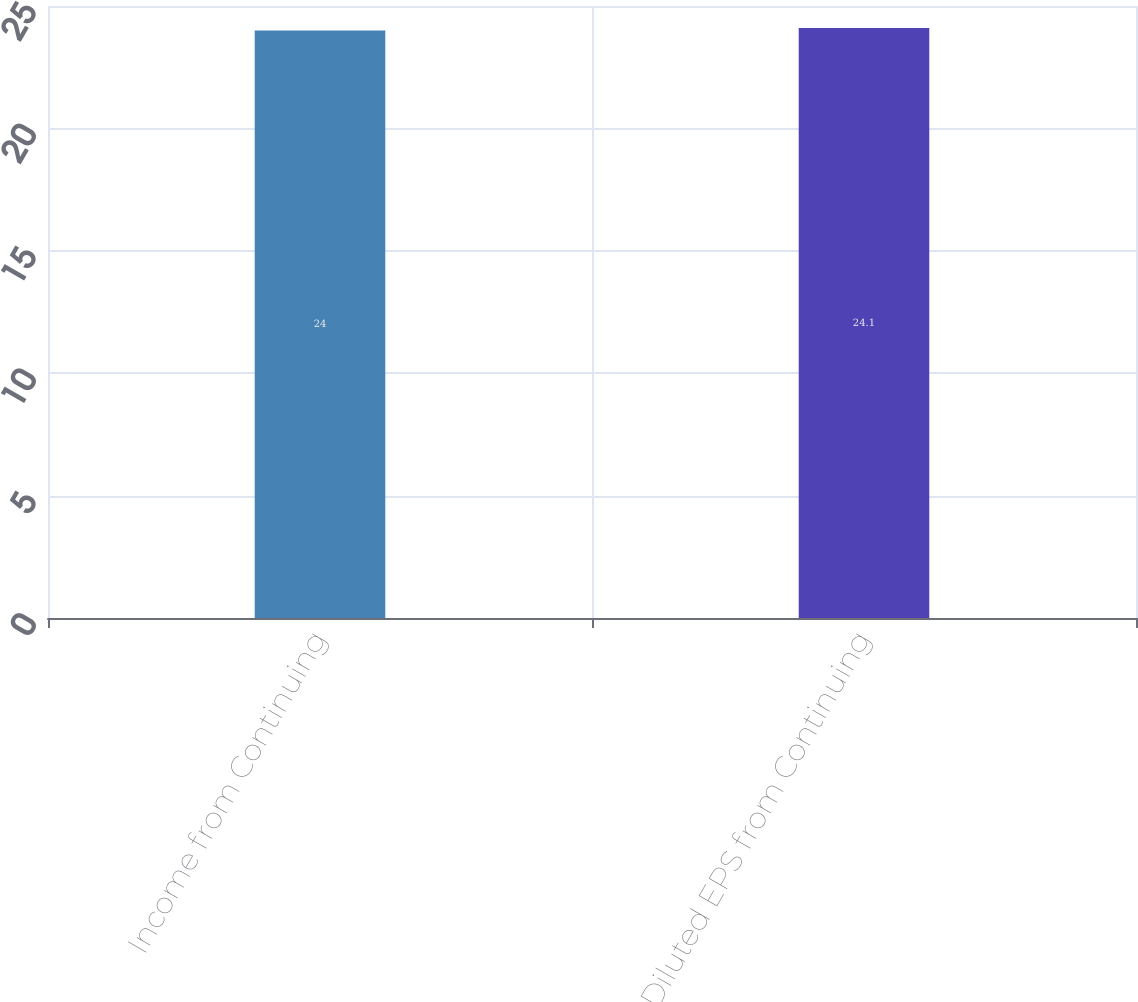Convert chart. <chart><loc_0><loc_0><loc_500><loc_500><bar_chart><fcel>Income from Continuing<fcel>Diluted EPS from Continuing<nl><fcel>24<fcel>24.1<nl></chart> 